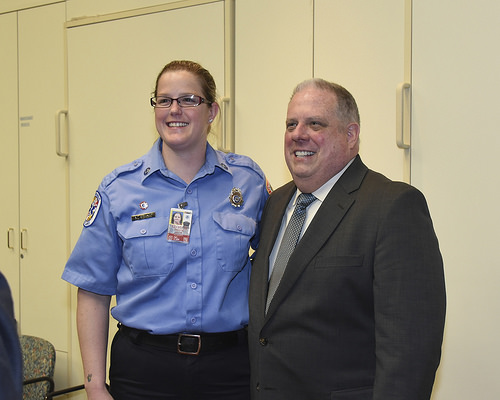<image>
Is the glasses on the person? No. The glasses is not positioned on the person. They may be near each other, but the glasses is not supported by or resting on top of the person. Where is the sally in relation to the jim? Is it to the right of the jim? Yes. From this viewpoint, the sally is positioned to the right side relative to the jim. 